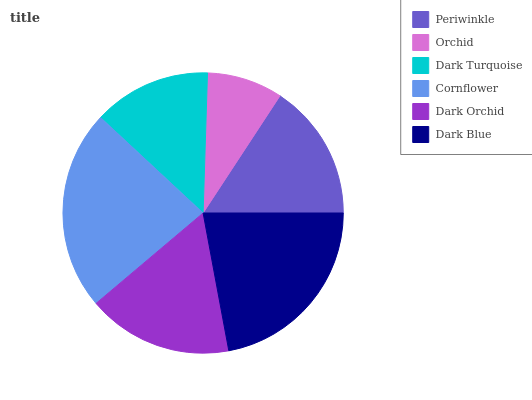Is Orchid the minimum?
Answer yes or no. Yes. Is Cornflower the maximum?
Answer yes or no. Yes. Is Dark Turquoise the minimum?
Answer yes or no. No. Is Dark Turquoise the maximum?
Answer yes or no. No. Is Dark Turquoise greater than Orchid?
Answer yes or no. Yes. Is Orchid less than Dark Turquoise?
Answer yes or no. Yes. Is Orchid greater than Dark Turquoise?
Answer yes or no. No. Is Dark Turquoise less than Orchid?
Answer yes or no. No. Is Dark Orchid the high median?
Answer yes or no. Yes. Is Periwinkle the low median?
Answer yes or no. Yes. Is Orchid the high median?
Answer yes or no. No. Is Dark Orchid the low median?
Answer yes or no. No. 